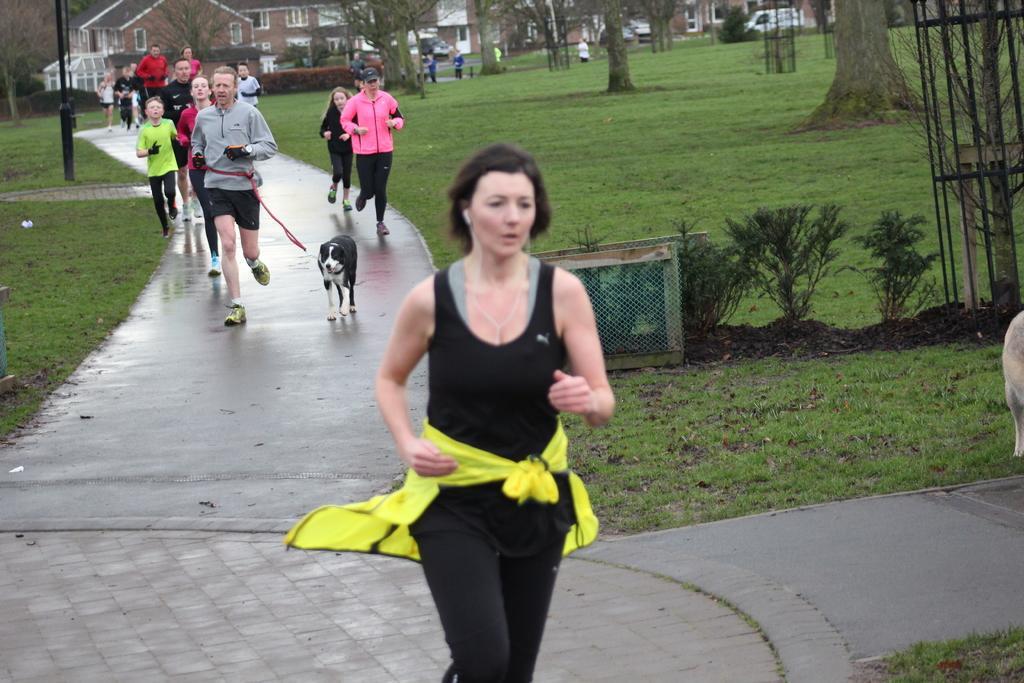Could you give a brief overview of what you see in this image? This picture shows few people running and we see a man running and holding a dog with the string in his hand and we see grass on the ground and we see trees and buildings. 